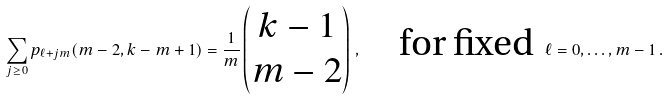<formula> <loc_0><loc_0><loc_500><loc_500>\sum _ { j \geq 0 } p _ { \ell + j m } ( m - 2 , k - m + 1 ) = \frac { 1 } { m } \begin{pmatrix} k - 1 \\ m - 2 \end{pmatrix} \, , \quad \text {for fixed } \, \ell = 0 , \dots , m - 1 \, .</formula> 